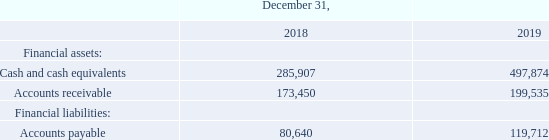NOTE 17. FINANCIAL INSTRUMENTS AND FINANCIAL RISK MANAGEMENT
FINANCIAL INSTRUMENTS
Financial instruments include:
The carrying amounts of cash and cash equivalents, accounts receivable and accounts payable equal their fair values because of the short-term nature of these instruments.
Why is the carrying amounts of the segments of financial instrustments equal to their fair values? Because of the short-term nature of these instruments. What is the Accounts receivable for 2018? 173,450. What is the Accounts payable for 2019? 119,712. What is the financial equity in 2018? 285,907+173,450-80,640
Answer: 378717. What is the change in accounts payable from 2018 to 2019? 119,712- 80,640 
Answer: 39072. Which year has the higher total financial assets? 2018:(285,907+173,450=459,357) 2019:(497,874 + 199,535=697,409)
Answer: 2019. 